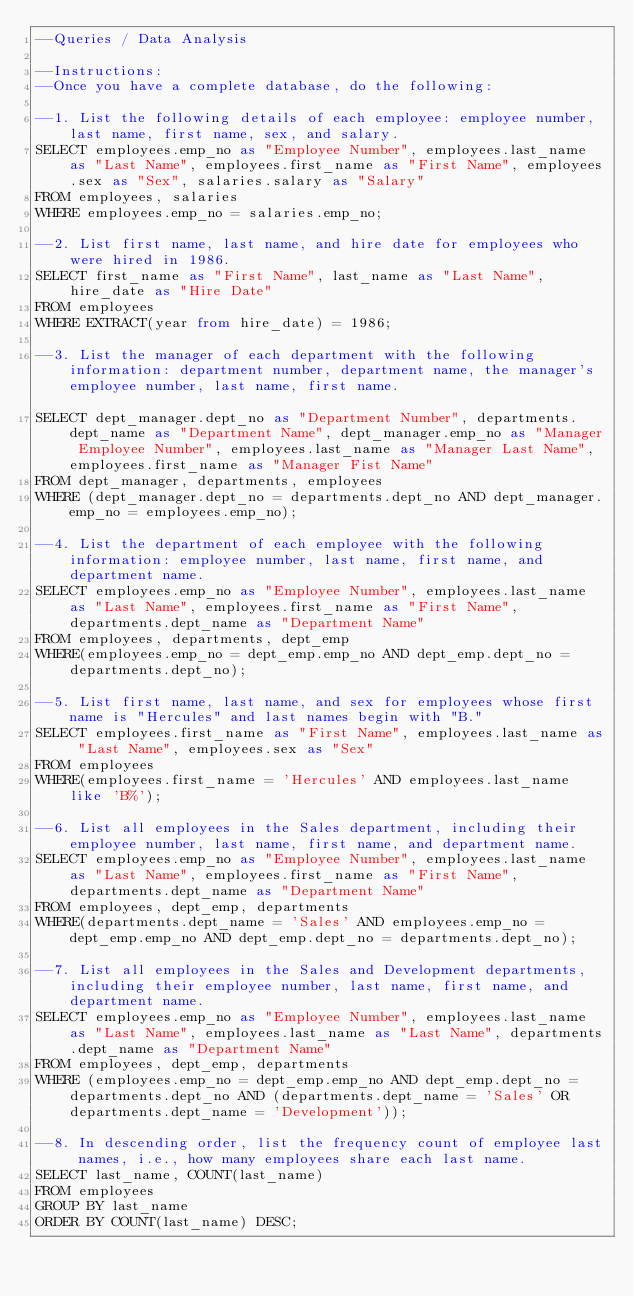<code> <loc_0><loc_0><loc_500><loc_500><_SQL_>--Queries / Data Analysis

--Instructions:
--Once you have a complete database, do the following:

--1. List the following details of each employee: employee number, last name, first name, sex, and salary.
SELECT employees.emp_no as "Employee Number", employees.last_name as "Last Name", employees.first_name as "First Name", employees.sex as "Sex", salaries.salary as "Salary"
FROM employees, salaries
WHERE employees.emp_no = salaries.emp_no;

--2. List first name, last name, and hire date for employees who were hired in 1986.
SELECT first_name as "First Name", last_name as "Last Name", hire_date as "Hire Date"
FROM employees
WHERE EXTRACT(year from hire_date) = 1986;

--3. List the manager of each department with the following information: department number, department name, the manager's employee number, last name, first name.															
SELECT dept_manager.dept_no as "Department Number", departments.dept_name as "Department Name", dept_manager.emp_no as "Manager Employee Number", employees.last_name as "Manager Last Name", employees.first_name as "Manager Fist Name"
FROM dept_manager, departments, employees
WHERE (dept_manager.dept_no = departments.dept_no AND dept_manager.emp_no = employees.emp_no);

--4. List the department of each employee with the following information: employee number, last name, first name, and department name.
SELECT employees.emp_no as "Employee Number", employees.last_name as "Last Name", employees.first_name as "First Name", departments.dept_name as "Department Name"
FROM employees, departments, dept_emp
WHERE(employees.emp_no = dept_emp.emp_no AND dept_emp.dept_no = departments.dept_no);

--5. List first name, last name, and sex for employees whose first name is "Hercules" and last names begin with "B."
SELECT employees.first_name as "First Name", employees.last_name as "Last Name", employees.sex as "Sex"
FROM employees
WHERE(employees.first_name = 'Hercules' AND employees.last_name like 'B%');

--6. List all employees in the Sales department, including their employee number, last name, first name, and department name.
SELECT employees.emp_no as "Employee Number", employees.last_name as "Last Name", employees.first_name as "First Name", departments.dept_name as "Department Name"
FROM employees, dept_emp, departments
WHERE(departments.dept_name = 'Sales' AND employees.emp_no = dept_emp.emp_no AND dept_emp.dept_no = departments.dept_no);

--7. List all employees in the Sales and Development departments, including their employee number, last name, first name, and department name.
SELECT employees.emp_no as "Employee Number", employees.last_name as "Last Name", employees.last_name as "Last Name", departments.dept_name as "Department Name"
FROM employees, dept_emp, departments
WHERE (employees.emp_no = dept_emp.emp_no AND dept_emp.dept_no = departments.dept_no AND (departments.dept_name = 'Sales' OR departments.dept_name = 'Development'));

--8. In descending order, list the frequency count of employee last names, i.e., how many employees share each last name.
SELECT last_name, COUNT(last_name)
FROM employees
GROUP BY last_name
ORDER BY COUNT(last_name) DESC;</code> 